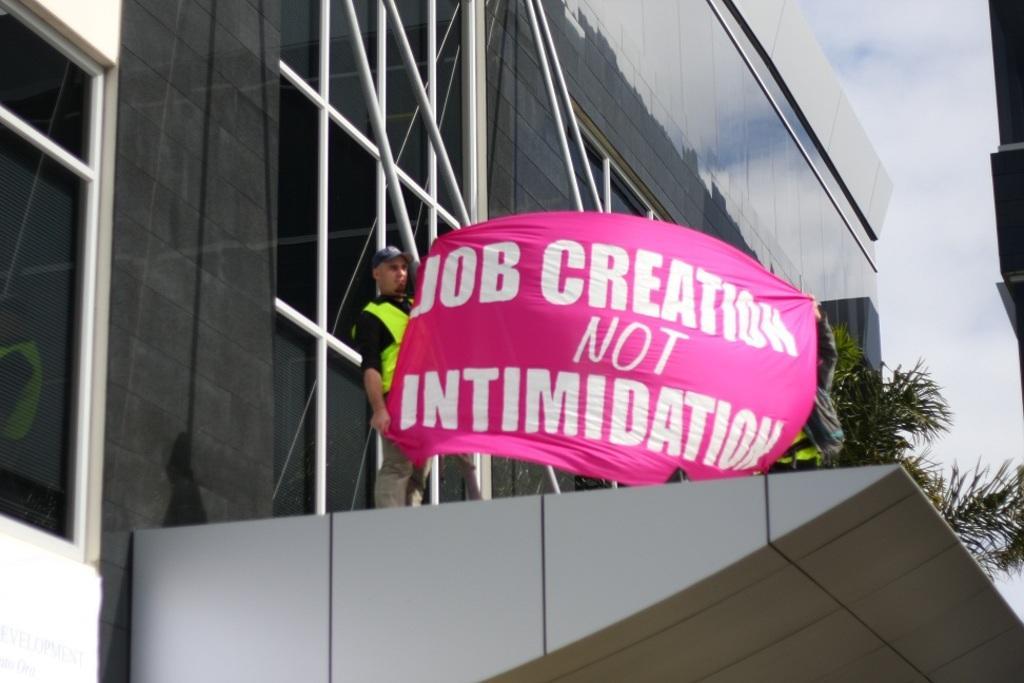How would you summarize this image in a sentence or two? In the center of the image there is a building and we can see two people standing on the building and holding a banner. In the background there is a tree and sky. 